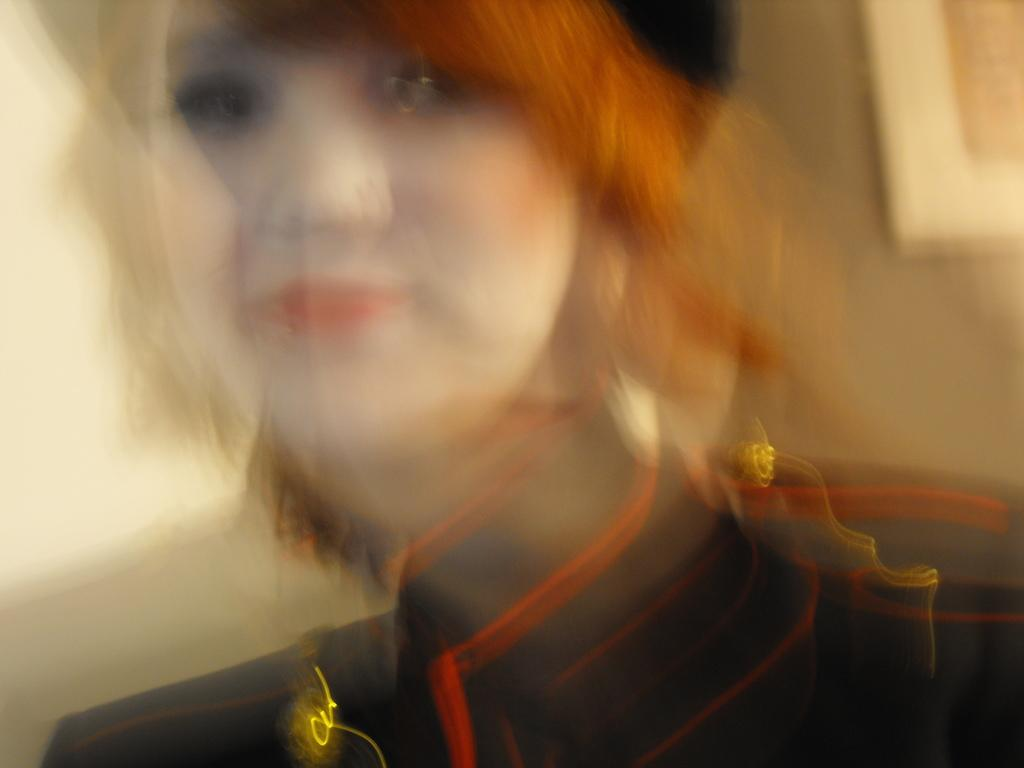What is the main subject of the image? The main subject of the image is a woman. What type of disgusting cream can be seen on the woman's face in the image? There is no cream, disgusting or otherwise, present on the woman's face in the image. 